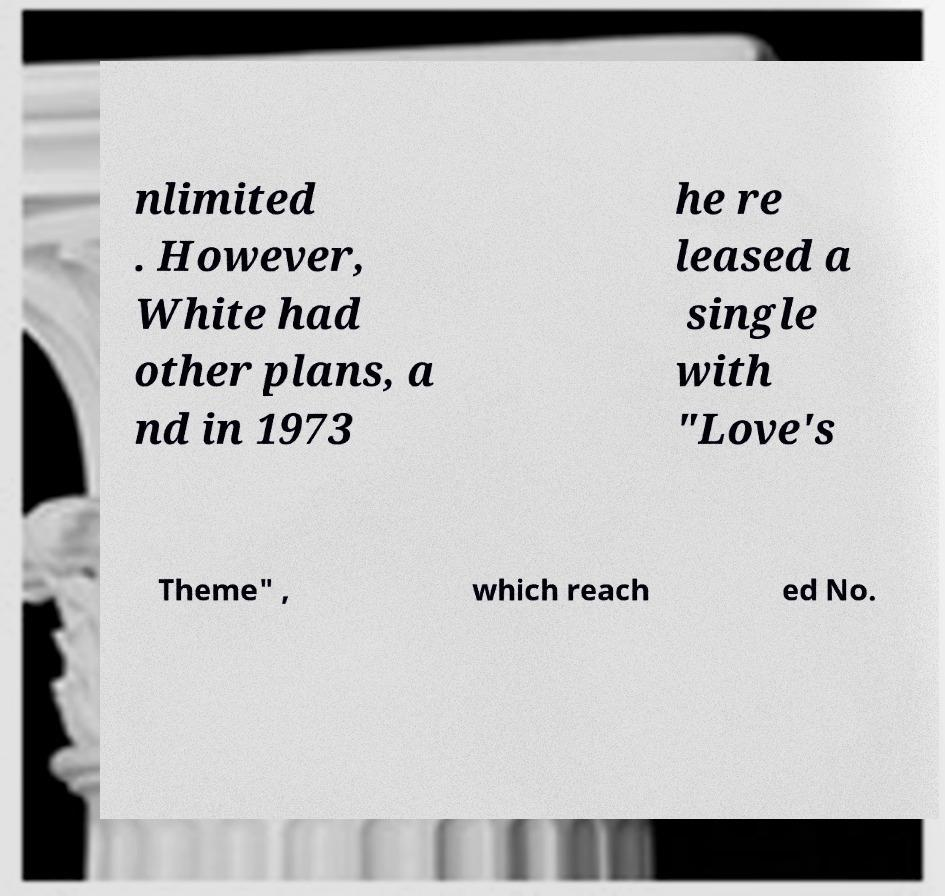Can you accurately transcribe the text from the provided image for me? nlimited . However, White had other plans, a nd in 1973 he re leased a single with "Love's Theme" , which reach ed No. 